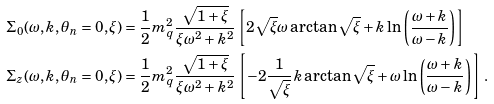<formula> <loc_0><loc_0><loc_500><loc_500>\Sigma _ { 0 } ( \omega , k , \theta _ { n } = 0 , \xi ) & = \frac { 1 } { 2 } m _ { q } ^ { 2 } \frac { \sqrt { 1 + \xi } } { \xi \omega ^ { 2 } + k ^ { 2 } } \left [ 2 \sqrt { \xi } \omega \arctan \sqrt { \xi } + k \ln \left ( \frac { \omega + k } { \omega - k } \right ) \right ] \\ \Sigma _ { z } ( \omega , k , \theta _ { n } = 0 , \xi ) & = \frac { 1 } { 2 } m _ { q } ^ { 2 } \frac { \sqrt { 1 + \xi } } { \xi \omega ^ { 2 } + k ^ { 2 } } \left [ - 2 \frac { 1 } { \sqrt { \xi } } k \arctan \sqrt { \xi } + \omega \ln \left ( \frac { \omega + k } { \omega - k } \right ) \right ] \, \text {.} \\</formula> 